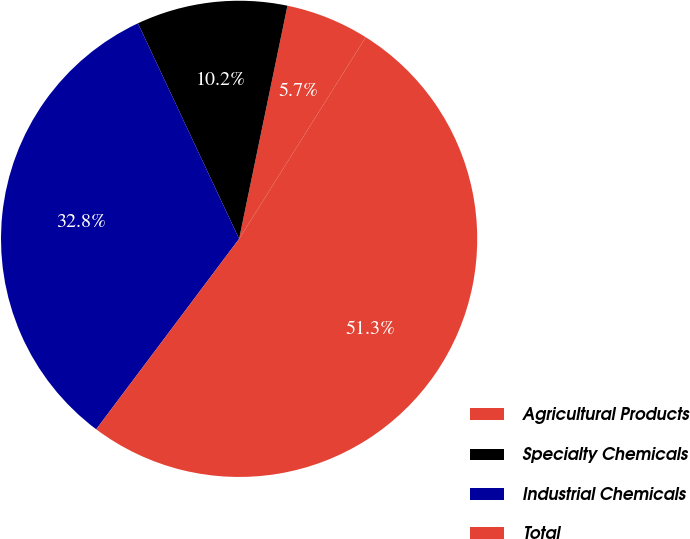Convert chart to OTSL. <chart><loc_0><loc_0><loc_500><loc_500><pie_chart><fcel>Agricultural Products<fcel>Specialty Chemicals<fcel>Industrial Chemicals<fcel>Total<nl><fcel>5.67%<fcel>10.24%<fcel>32.77%<fcel>51.32%<nl></chart> 